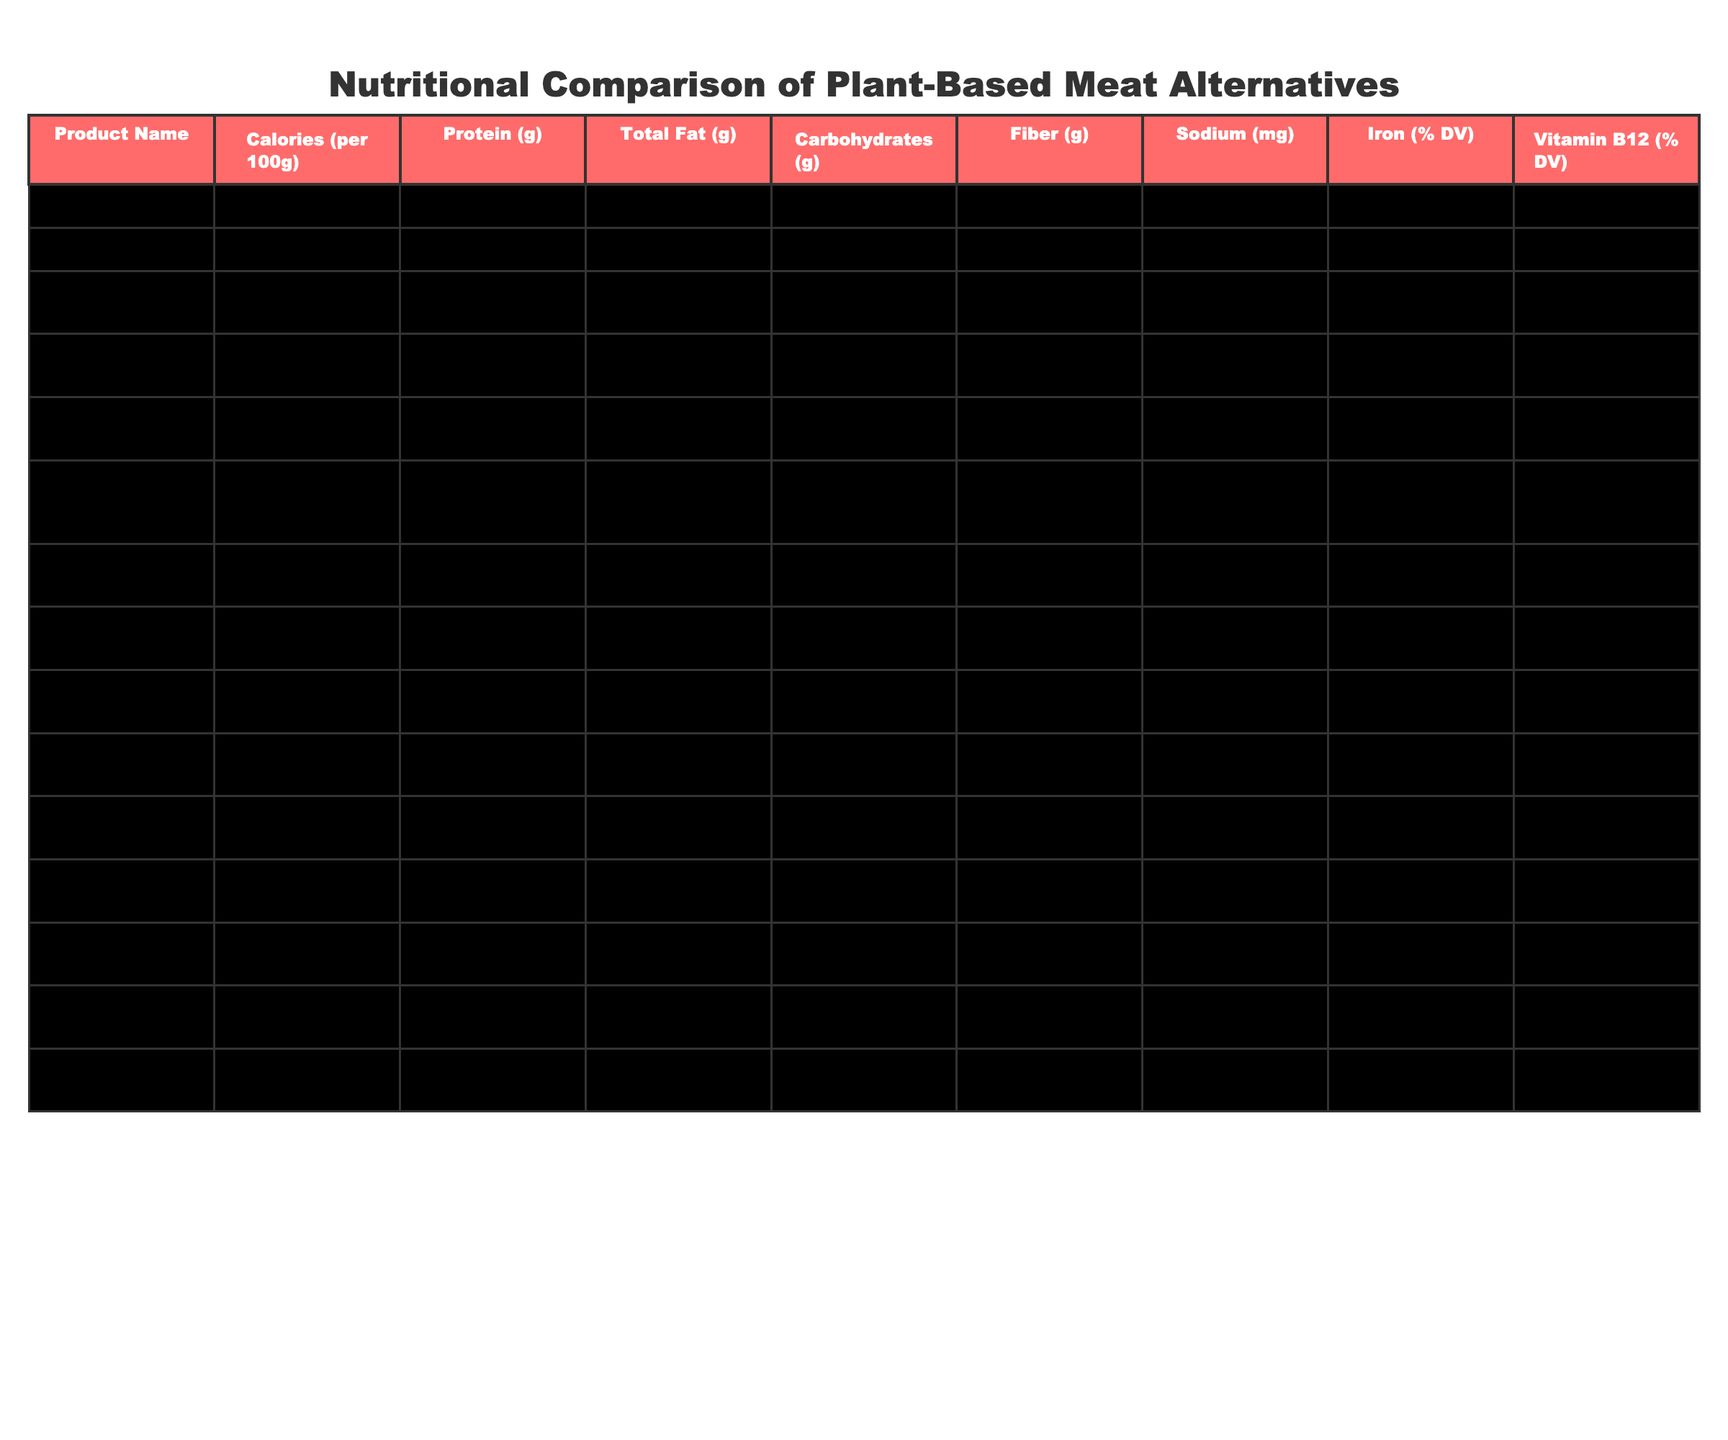What is the product with the highest protein content per 100g? The highest protein content is found in the Field Roast Italian Sausage, which contains 25 grams of protein per 100g.
Answer: Field Roast Italian Sausage What is the calorie difference between the Beyond Burger and the Tofurky Plant-Based Burger? The Beyond Burger has 250 calories, while the Tofurky Plant-Based Burger has 260 calories. The difference is 260 - 250 = 10 calories.
Answer: 10 calories Which product has the lowest amount of total fat? Quorn Meatless Pieces has the lowest total fat content at 2 grams per 100g.
Answer: Quorn Meatless Pieces Is the Impossible Burger higher in calories than the Boca All American Veggie Burger? The Impossible Burger has 240 calories, while the Boca All American Veggie Burger has 160 calories. Therefore, it is true that the Impossible Burger is higher in calories.
Answer: Yes What is the average sodium content of the products listed? The sum of sodium content is 390 + 370 + 140 + 420 + 500 + 500 + 510 + 740 + 350 + 330 + 450 + 390 + 380 + 320 =  5820 mg. There are 14 products, so the average sodium is 5820 / 14 = 415 mg.
Answer: 415 mg Which product has the highest iron percentage of daily value? The product with the highest iron percentage is the Impossible Burger, which provides 30% of the daily value.
Answer: Impossible Burger Is the fiber content of the Sweet Earth Awesome Burger higher than the MorningStar Farms Grillers Original? The Sweet Earth Awesome Burger has 2 grams of fiber while the MorningStar Farms Grillers Original has 4 grams. Thus, Sweet Earth Awesome Burger has lower fiber content.
Answer: No How would you describe the average calories of all the products in the table? The total calories calculated from all products is 250 + 240 + 105 + 230 + 260 + 220 + 220 + 280 + 160 + 230 + 260 + 150 + 180 + 120 + 210 =  2900 calories. The average number of calories is 2900 / 15 = 193.3 calories per product.
Answer: 193.3 calories Are there any products that provide Vitamin B12? Yes, the products that provide Vitamin B12 are the Beyond Burger, Impossible Burger, Gardein Ultimate Plant-Based Burger, Tofurky Plant-Based Burger, MorningStar Farms Grillers Original, Ozo Plant-Based Burger, and Sweet Earth Awesome Burger.
Answer: Yes Which product's total carbohydrates are closest to 7 grams? The Tofurky Plant-Based Burger and MorningStar Farms Grillers Original both have 7 grams of carbohydrates each, making them the closest to 7 grams.
Answer: Tofurky Plant-Based Burger, MorningStar Farms Grillers Original 